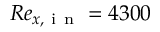<formula> <loc_0><loc_0><loc_500><loc_500>R e _ { x , i n } = 4 3 0 0</formula> 